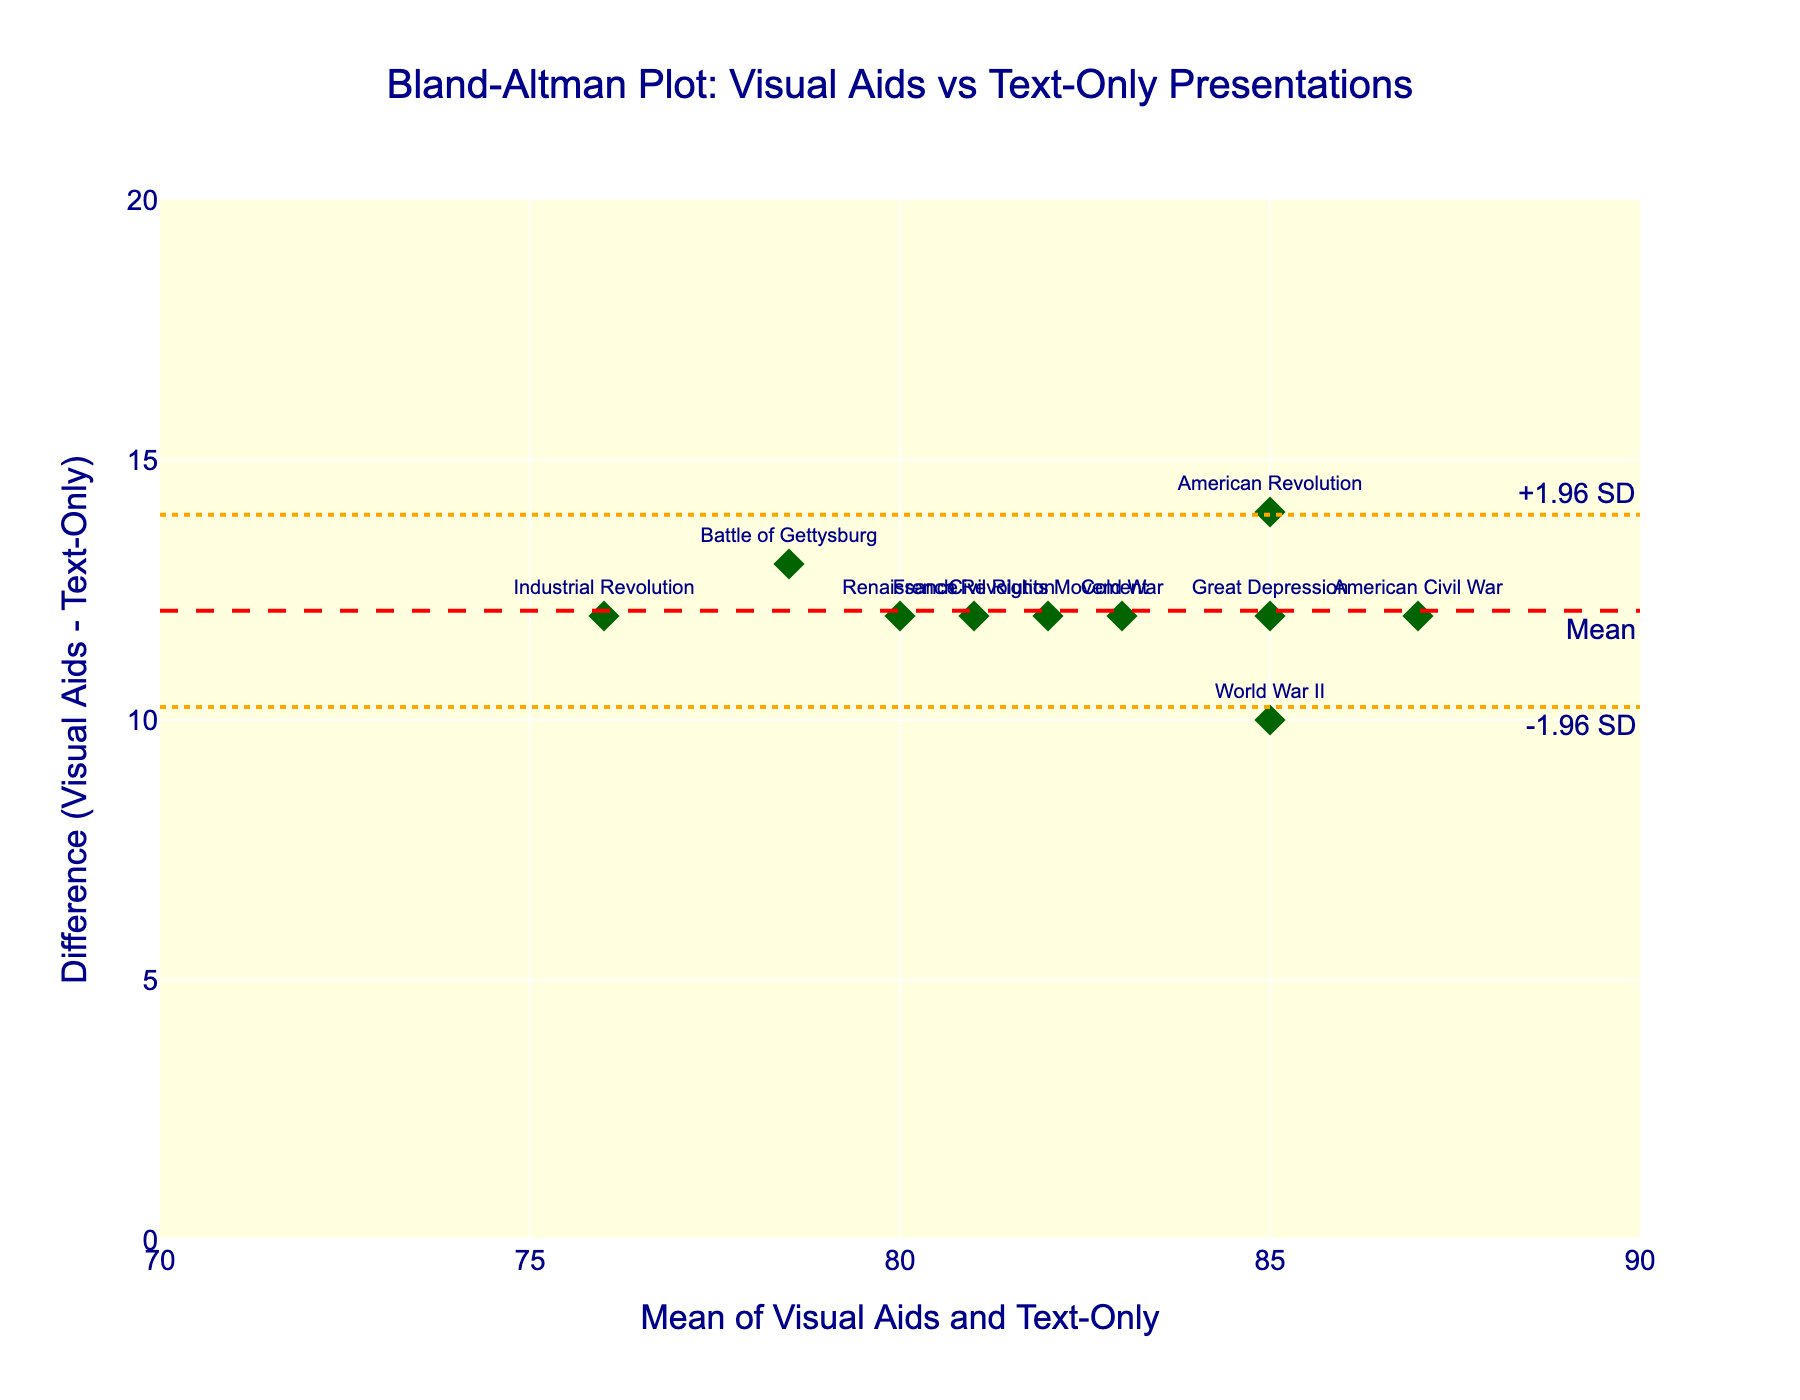What is the title of the plot? The title is displayed prominently at the top-center of the plot. It reads, "Bland-Altman Plot: Visual Aids vs Text-Only Presentations".
Answer: Bland-Altman Plot: Visual Aids vs Text-Only Presentations What do the red dashed and orange dotted lines on the plot represent? The red dashed line represents the mean difference, and the orange dotted lines represent the upper and lower limits of agreement (+/- 1.96 standard deviations from the mean difference).
Answer: The mean difference and limits of agreement What is the mean difference between Visual Aids and Text-Only recall scores? The mean difference is represented by the red dashed line and is annotated with "Mean".
Answer: Approximately 9 Which historical event has the largest positive difference between Visual Aids and Text-Only scores? Locate the highest point on the vertical axis and check the label of the associated data point. The highest difference is for the "American Civil War".
Answer: American Civil War Which historical event has the smallest mean score, and what is that score? Find the smallest value on the horizontal axis and check the label of the associated data point, which is "Industrial Revolution" with a mean score of 76.
Answer: Industrial Revolution, 76 Are there any historical events with the same mean score? If yes, name them. Check for data points aligned vertically or those with the same x-value. "American Revolution", "World War II", and "Great Depression" all have the same mean score of 85.
Answer: American Revolution, World War II, Great Depression What is the range of the mean scores plotted on the horizontal axis? Identify the minimum and maximum values on the horizontal axis, which range from 76 (Industrial Revolution) to 87 (American Civil War).
Answer: 76 to 87 How many historical events have positive differences between Visual Aids and Text-Only scores? Count the number of data points above the horizontal axis where the difference is greater than 0. There are 10 such events.
Answer: 10 Does any historical event fall outside the limits of agreement (+1.96 SD and -1.96 SD)? Check if any data points lie beyond the orange dotted lines on the y-axis. None of the points fall outside these limits.
Answer: No 